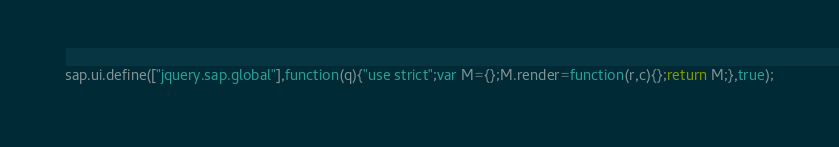Convert code to text. <code><loc_0><loc_0><loc_500><loc_500><_JavaScript_>sap.ui.define(["jquery.sap.global"],function(q){"use strict";var M={};M.render=function(r,c){};return M;},true);
</code> 